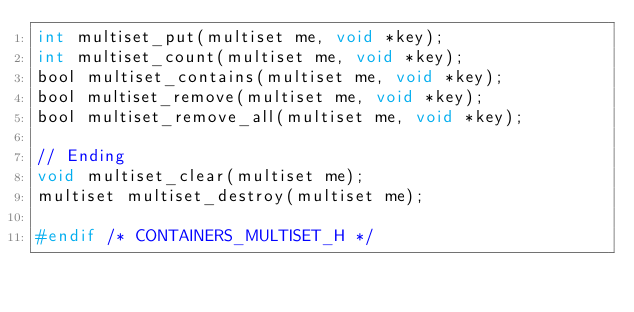Convert code to text. <code><loc_0><loc_0><loc_500><loc_500><_C_>int multiset_put(multiset me, void *key);
int multiset_count(multiset me, void *key);
bool multiset_contains(multiset me, void *key);
bool multiset_remove(multiset me, void *key);
bool multiset_remove_all(multiset me, void *key);

// Ending
void multiset_clear(multiset me);
multiset multiset_destroy(multiset me);

#endif /* CONTAINERS_MULTISET_H */
</code> 